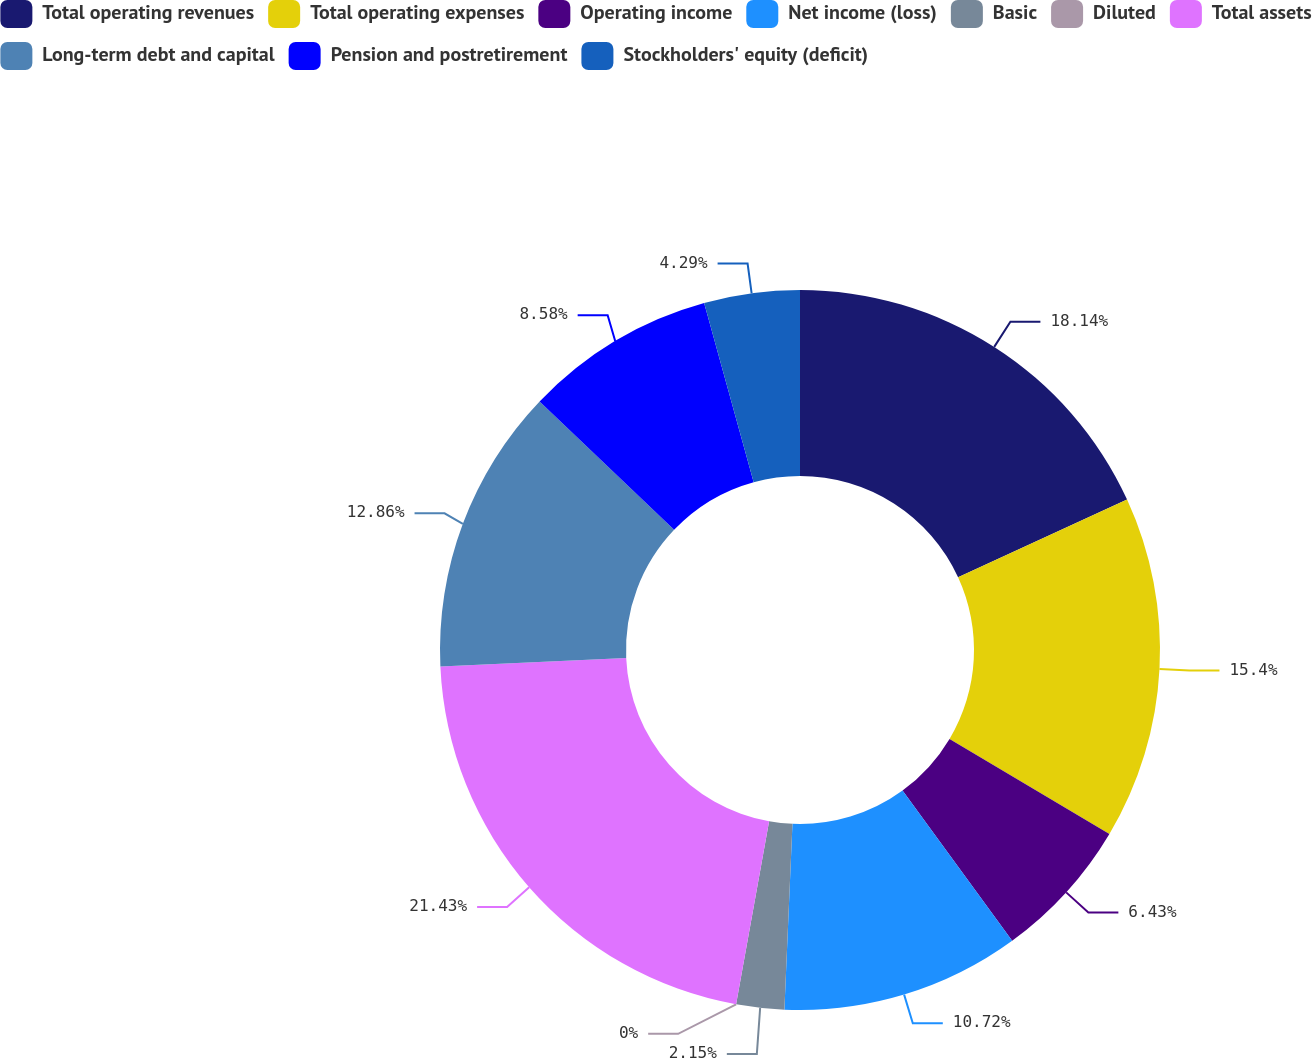Convert chart to OTSL. <chart><loc_0><loc_0><loc_500><loc_500><pie_chart><fcel>Total operating revenues<fcel>Total operating expenses<fcel>Operating income<fcel>Net income (loss)<fcel>Basic<fcel>Diluted<fcel>Total assets<fcel>Long-term debt and capital<fcel>Pension and postretirement<fcel>Stockholders' equity (deficit)<nl><fcel>18.14%<fcel>15.4%<fcel>6.43%<fcel>10.72%<fcel>2.15%<fcel>0.0%<fcel>21.43%<fcel>12.86%<fcel>8.58%<fcel>4.29%<nl></chart> 